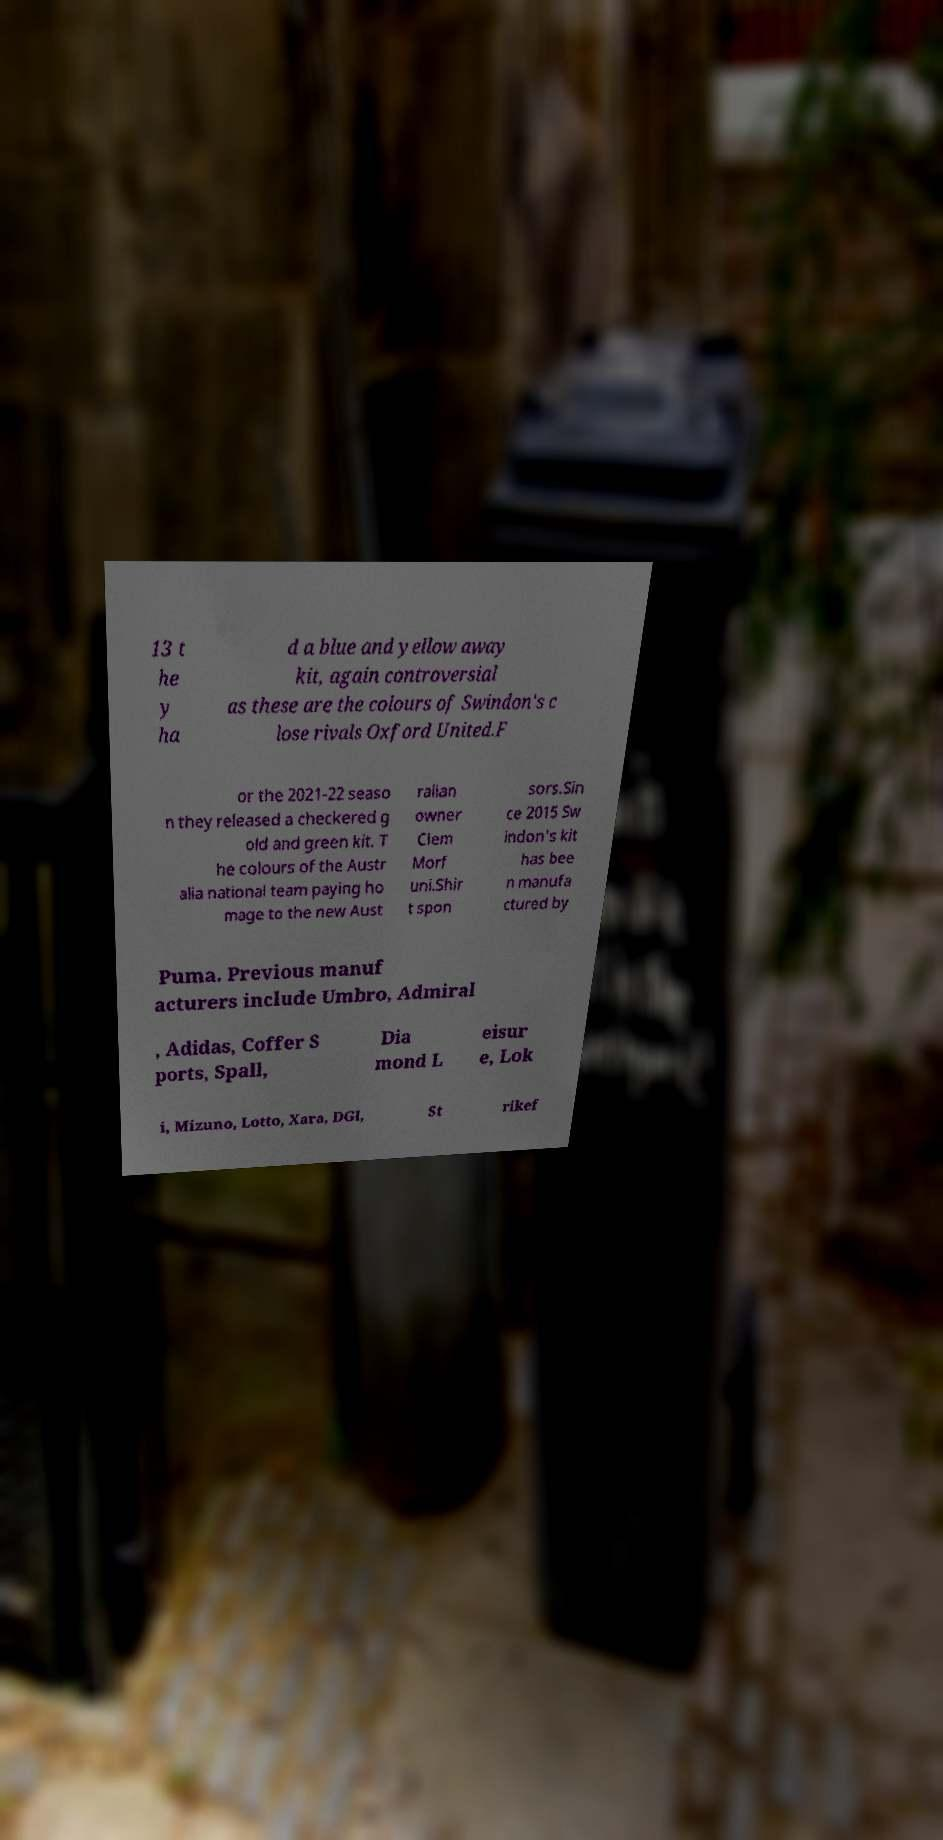Can you accurately transcribe the text from the provided image for me? 13 t he y ha d a blue and yellow away kit, again controversial as these are the colours of Swindon's c lose rivals Oxford United.F or the 2021-22 seaso n they released a checkered g old and green kit. T he colours of the Austr alia national team paying ho mage to the new Aust ralian owner Clem Morf uni.Shir t spon sors.Sin ce 2015 Sw indon's kit has bee n manufa ctured by Puma. Previous manuf acturers include Umbro, Admiral , Adidas, Coffer S ports, Spall, Dia mond L eisur e, Lok i, Mizuno, Lotto, Xara, DGI, St rikef 